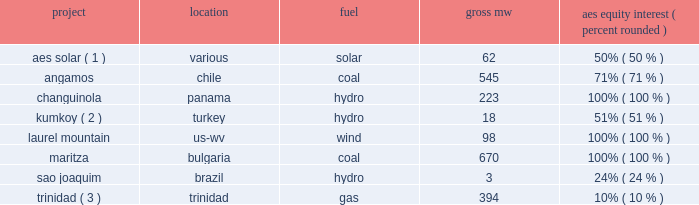Management 2019s priorities management has re-evaluated its priorities following the appointment of its new ceo in september 2011 .
Management is focused on the following priorities : 2022 execution of our geographic concentration strategy to maximize shareholder value through disciplined capital allocation including : 2022 platform expansion in brazil , chile , colombia , and the united states , 2022 platform development in turkey , poland , and the united kingdom , 2022 corporate debt reduction , and 2022 a return of capital to shareholders , including our intent to initiate a dividend in 2012 ; 2022 closing the sales of businesses for which we have signed agreements with counterparties and prudently exiting select non-strategic markets ; 2022 optimizing profitability of operations in the existing portfolio ; 2022 integration of dpl into our portfolio ; 2022 implementing a management realignment of our businesses under two business lines : utilities and generation , and achieving cost savings through the alignment of overhead costs with business requirements , systems automation and optimal allocation of business development spending ; and 2022 completion of an approximately 2400 mw construction program and the integration of new projects into existing businesses .
During the year ended december 31 , 2011 , the following projects commenced commercial operations : project location fuel aes equity interest ( percent , rounded ) aes solar ( 1 ) .
Various solar 62 50% ( 50 % ) .
Trinidad ( 3 ) .
Trinidad gas 394 10% ( 10 % ) ( 1 ) aes solar energy ltd .
Is a joint venture with riverstone holdings and is accounted for as an equity method investment .
Plants that came online during the year include : kalipetrovo , ugento , soemina , francavilla fontana , latina , cocomeri , francofonte , scopeto , sabaudia , aprilla-1 , siracusa 1-3 complex , manduria apollo and rinaldone .
( 2 ) joint venture with i.c .
Energy .
( 3 ) an equity method investment held by aes .
Key trends and uncertainties our operations continue to face many risks as discussed in item 1a . 2014risk factors of this form 10-k .
Some of these challenges are also described below in 201ckey drivers of results in 2011 201d .
We continue to monitor our operations and address challenges as they arise .
Operations in august 2010 , the esti power plant , a 120 mw run-of-river hydroelectric power plant in panama , was taken offline due to damage to its tunnel infrastructure .
Aes panama is partially covered for business .
Was the company's us project capacity greeter than the capacity in bulgaria? 
Computations: (98 > 670)
Answer: no. 